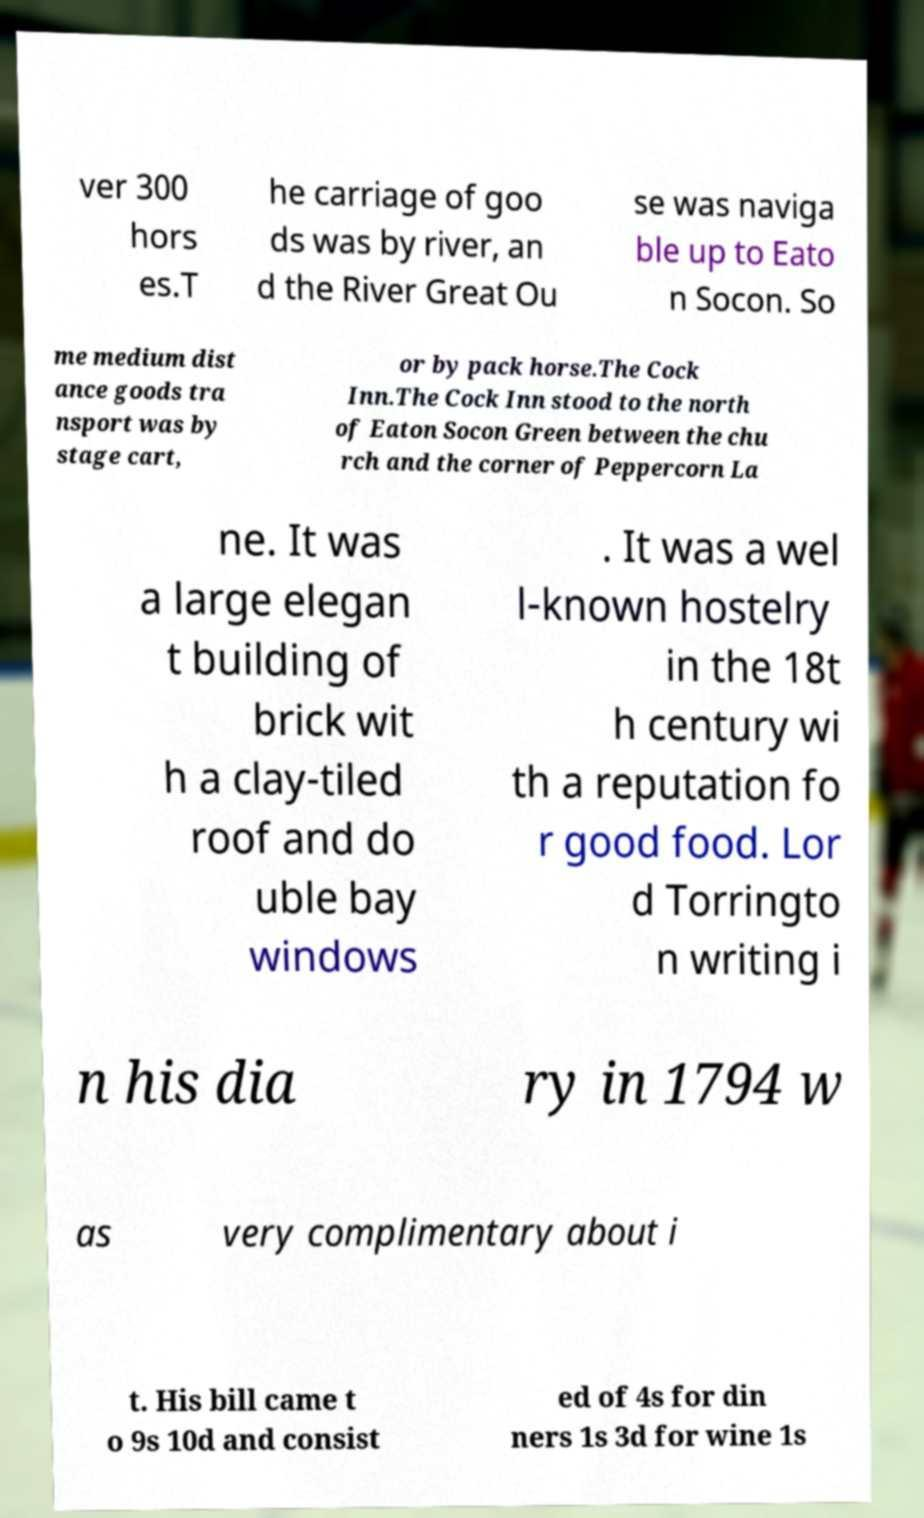Please read and relay the text visible in this image. What does it say? ver 300 hors es.T he carriage of goo ds was by river, an d the River Great Ou se was naviga ble up to Eato n Socon. So me medium dist ance goods tra nsport was by stage cart, or by pack horse.The Cock Inn.The Cock Inn stood to the north of Eaton Socon Green between the chu rch and the corner of Peppercorn La ne. It was a large elegan t building of brick wit h a clay-tiled roof and do uble bay windows . It was a wel l-known hostelry in the 18t h century wi th a reputation fo r good food. Lor d Torringto n writing i n his dia ry in 1794 w as very complimentary about i t. His bill came t o 9s 10d and consist ed of 4s for din ners 1s 3d for wine 1s 